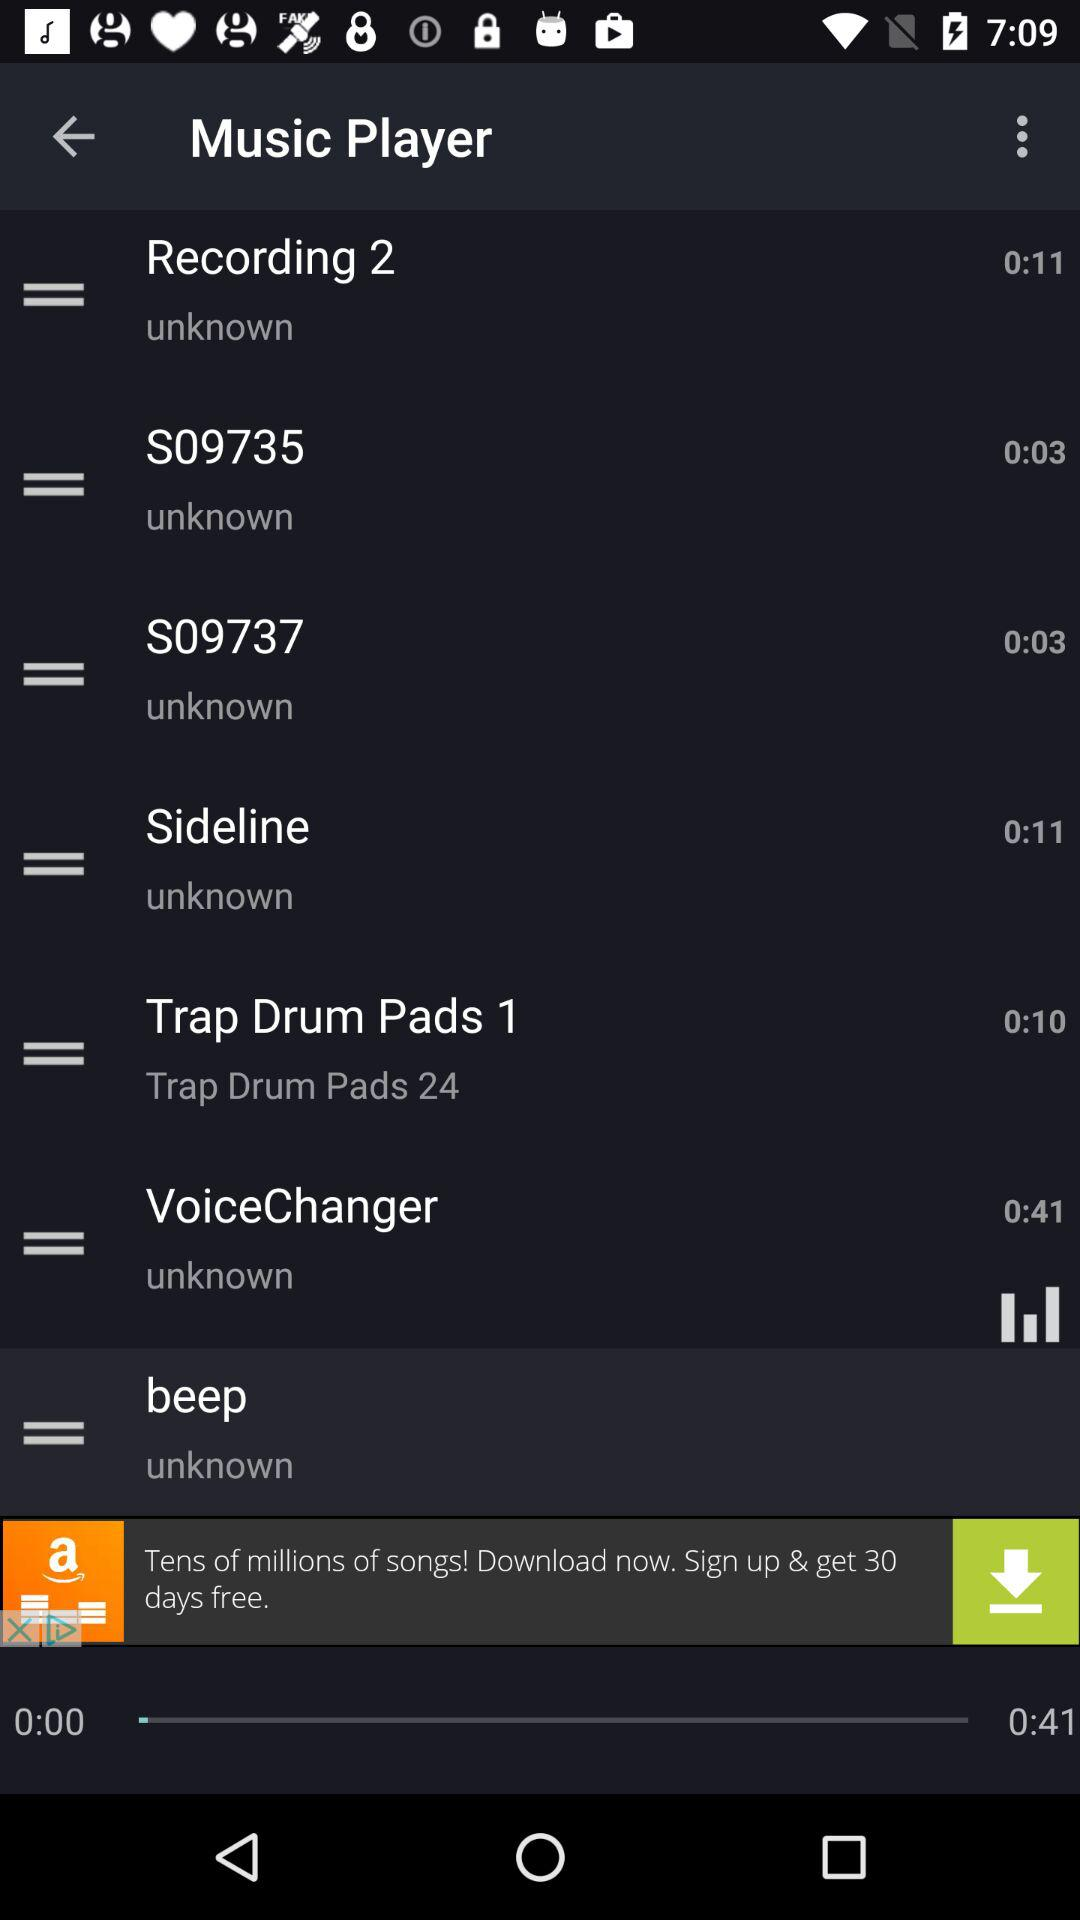Which music has a duration of 0:03? The music is "S09735" and "S09737". 